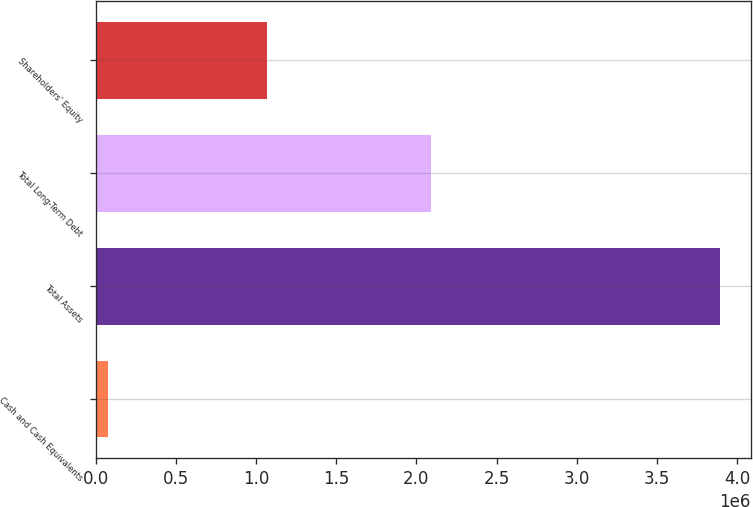Convert chart. <chart><loc_0><loc_0><loc_500><loc_500><bar_chart><fcel>Cash and Cash Equivalents<fcel>Total Assets<fcel>Total Long-Term Debt<fcel>Shareholders' Equity<nl><fcel>74683<fcel>3.8921e+06<fcel>2.08993e+06<fcel>1.06611e+06<nl></chart> 